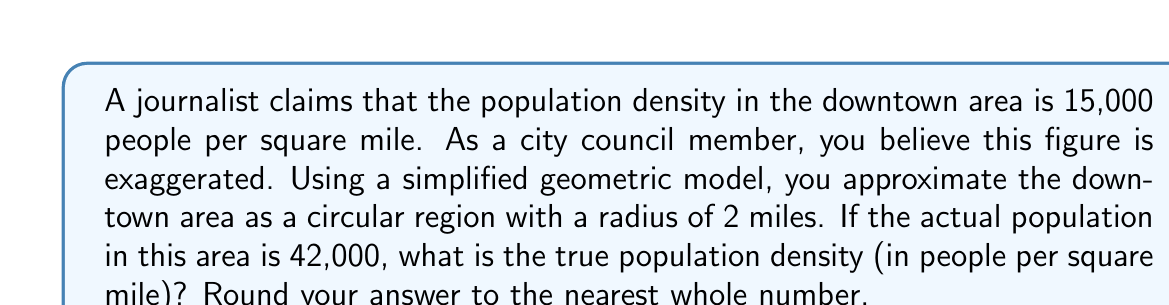Provide a solution to this math problem. Let's approach this step-by-step:

1) First, we need to calculate the area of the downtown region. Since it's modeled as a circle with a radius of 2 miles, we use the formula:

   $$A = \pi r^2$$

   Where $A$ is the area and $r$ is the radius.

2) Plugging in the values:

   $$A = \pi (2)^2 = 4\pi \text{ square miles}$$

3) Now, we know that population density is calculated by dividing the total population by the area:

   $$\text{Population Density} = \frac{\text{Total Population}}{\text{Area}}$$

4) We're given that the actual population is 42,000. So:

   $$\text{Population Density} = \frac{42,000}{4\pi} \text{ people per square mile}$$

5) Let's calculate this:

   $$\frac{42,000}{4\pi} \approx 3,342.45 \text{ people per square mile}$$

6) Rounding to the nearest whole number:

   3,342 people per square mile

This calculation shows that the journalist's claim of 15,000 people per square mile is indeed significantly higher than the actual density.
Answer: 3,342 people/sq mile 